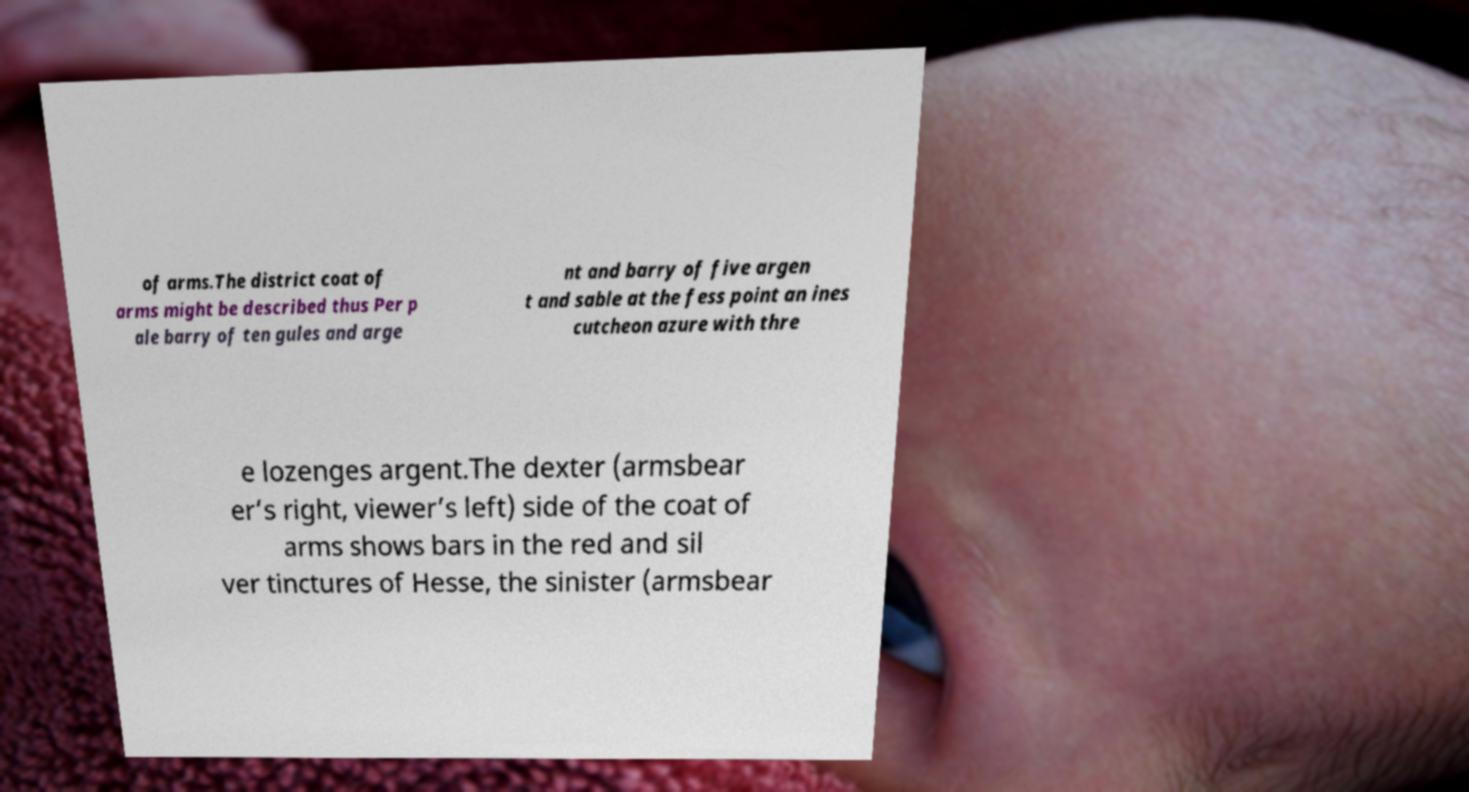Could you assist in decoding the text presented in this image and type it out clearly? of arms.The district coat of arms might be described thus Per p ale barry of ten gules and arge nt and barry of five argen t and sable at the fess point an ines cutcheon azure with thre e lozenges argent.The dexter (armsbear er’s right, viewer’s left) side of the coat of arms shows bars in the red and sil ver tinctures of Hesse, the sinister (armsbear 